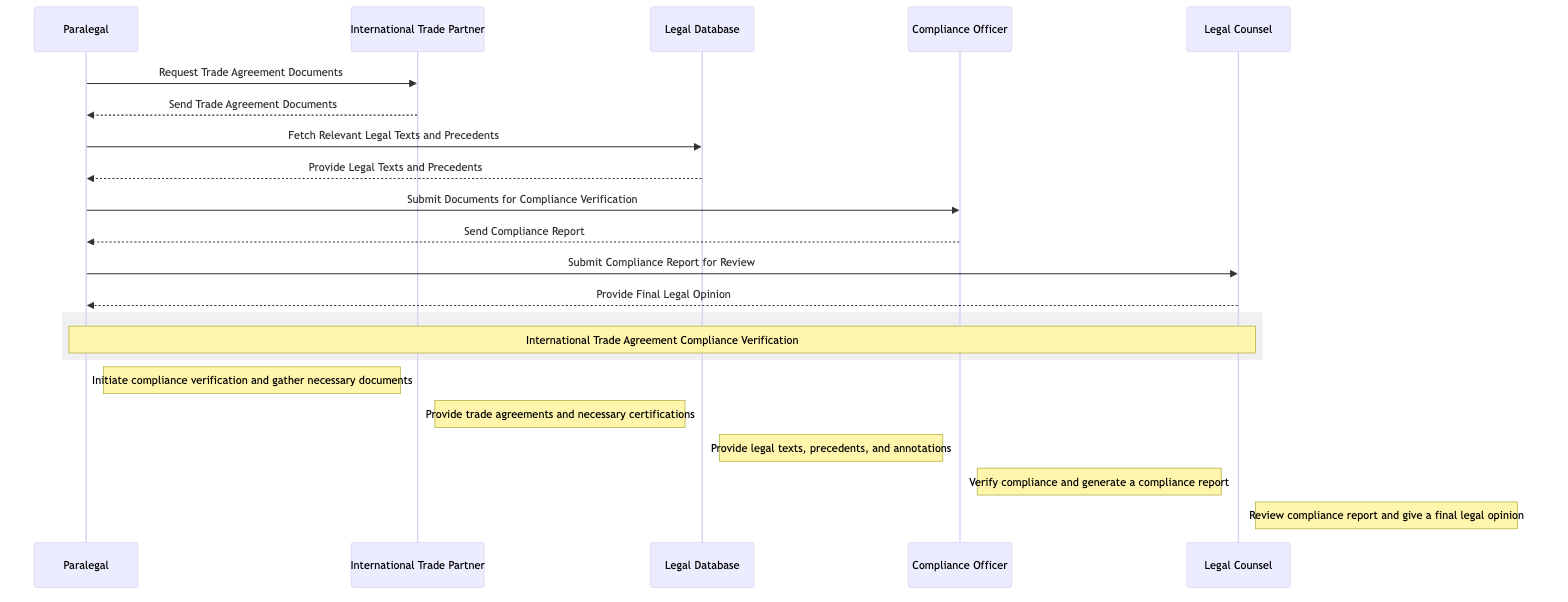What is the first action taken in the compliance verification process? The first action taken is by the Paralegal who requests Trade Agreement Documents from the International Trade Partner. This is indicated as the initial message from Paralegal to International Trade Partner in the sequence diagram.
Answer: Request Trade Agreement Documents How many actors are involved in this sequence diagram? By counting the listed participants, we note that there are five actors: Paralegal, International Trade Partner, Legal Database, Compliance Officer, and Legal Counsel.
Answer: 5 What type of document does the Compliance Officer generate? The Compliance Officer generates a Compliance Report as indicated by the message from Compliance Officer back to Paralegal. This report indicates the compliance status of the trade agreement.
Answer: Compliance Report Who is responsible for reviewing the Compliance Report? The Legal Counsel is responsible for reviewing the Compliance Report, as shown by the message directing from Paralegal to Legal Counsel to submit this report for review.
Answer: Legal Counsel What is the last step in the compliance verification process? The last step is when the Legal Counsel provides a final legal opinion to the Paralegal based on the compliance report reviewed. This forms the final response in the sequence of actions.
Answer: Provide Final Legal Opinion What document does the Paralegal submit for compliance verification? The Paralegal submits the Trade Agreement Documents for compliance verification to the Compliance Officer, which is the message sent before the Compliance Report is generated.
Answer: Trade Agreement Documents Which actor provides legal texts and precedents? The Legal Database provides legal texts and precedents as indicated by the message exchanged between Paralegal and Legal Database in the sequence.
Answer: Legal Database How many synchronous messages are there in total? Counting each message from actor to actor, there are a total of seven synchronous messages exchanged in this sequence diagram.
Answer: 7 What action follows after the Compliance Officer sends the Compliance Report? The action that follows is that the Paralegal submits the Compliance Report for review to the Legal Counsel, as reflected in the next message sequence after the receipt of the Compliance Report.
Answer: Submit Compliance Report for Review 